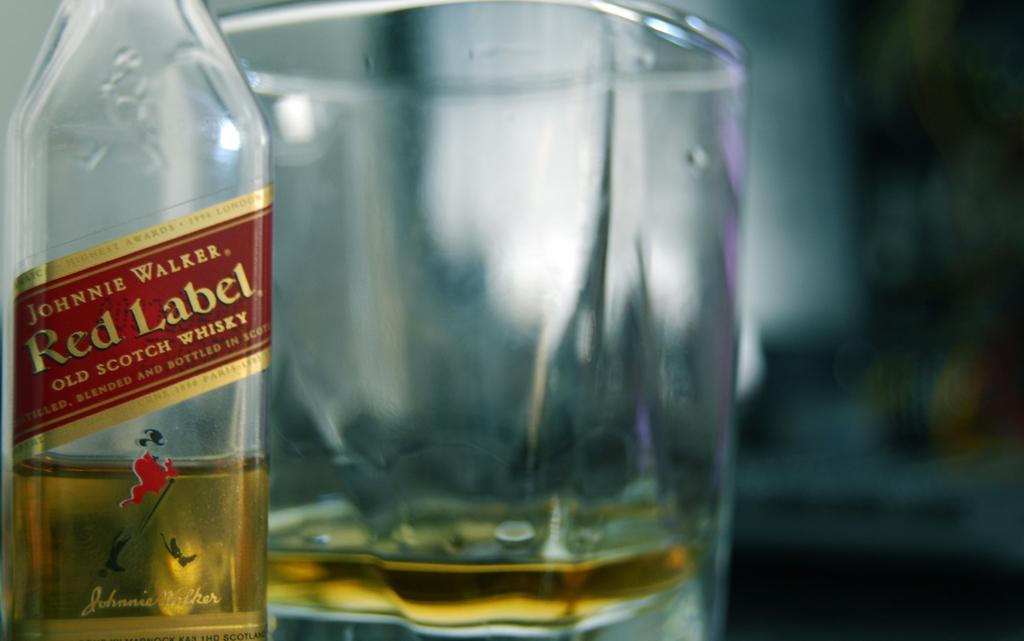Which company made the whisky?
Make the answer very short. Johnnie walker. 